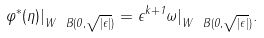<formula> <loc_0><loc_0><loc_500><loc_500>\varphi ^ { \ast } ( \eta ) | _ { W \ B ( 0 , \sqrt { | \epsilon | } ) } = \epsilon ^ { k + 1 } \omega | _ { W \ B ( 0 , \sqrt { | \epsilon | } ) } .</formula> 